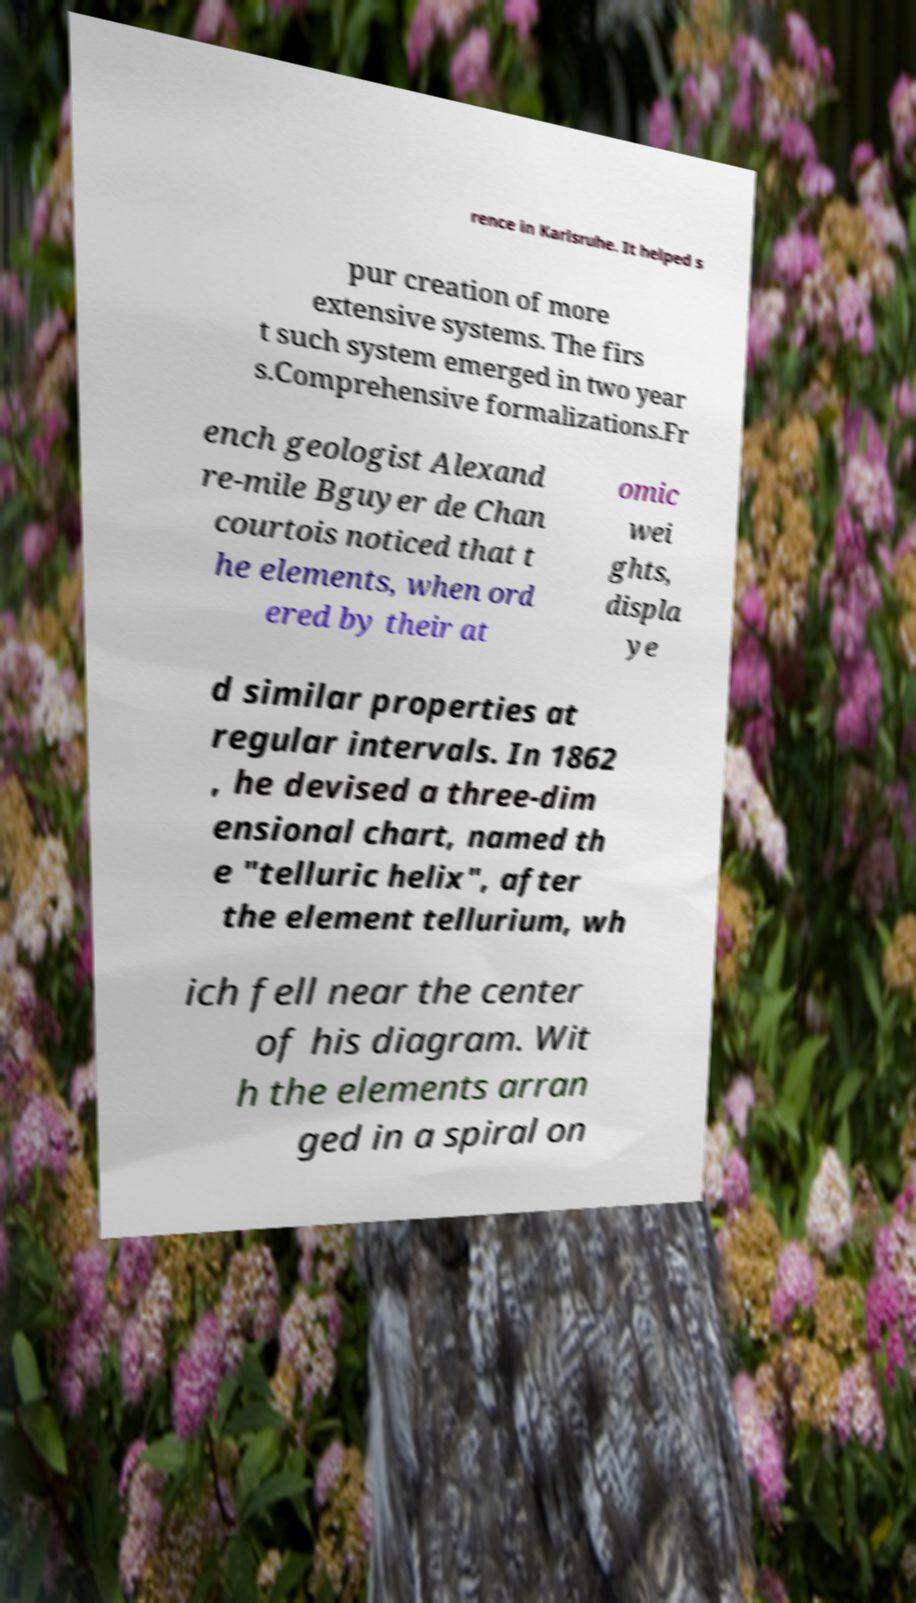There's text embedded in this image that I need extracted. Can you transcribe it verbatim? rence in Karlsruhe. It helped s pur creation of more extensive systems. The firs t such system emerged in two year s.Comprehensive formalizations.Fr ench geologist Alexand re-mile Bguyer de Chan courtois noticed that t he elements, when ord ered by their at omic wei ghts, displa ye d similar properties at regular intervals. In 1862 , he devised a three-dim ensional chart, named th e "telluric helix", after the element tellurium, wh ich fell near the center of his diagram. Wit h the elements arran ged in a spiral on 